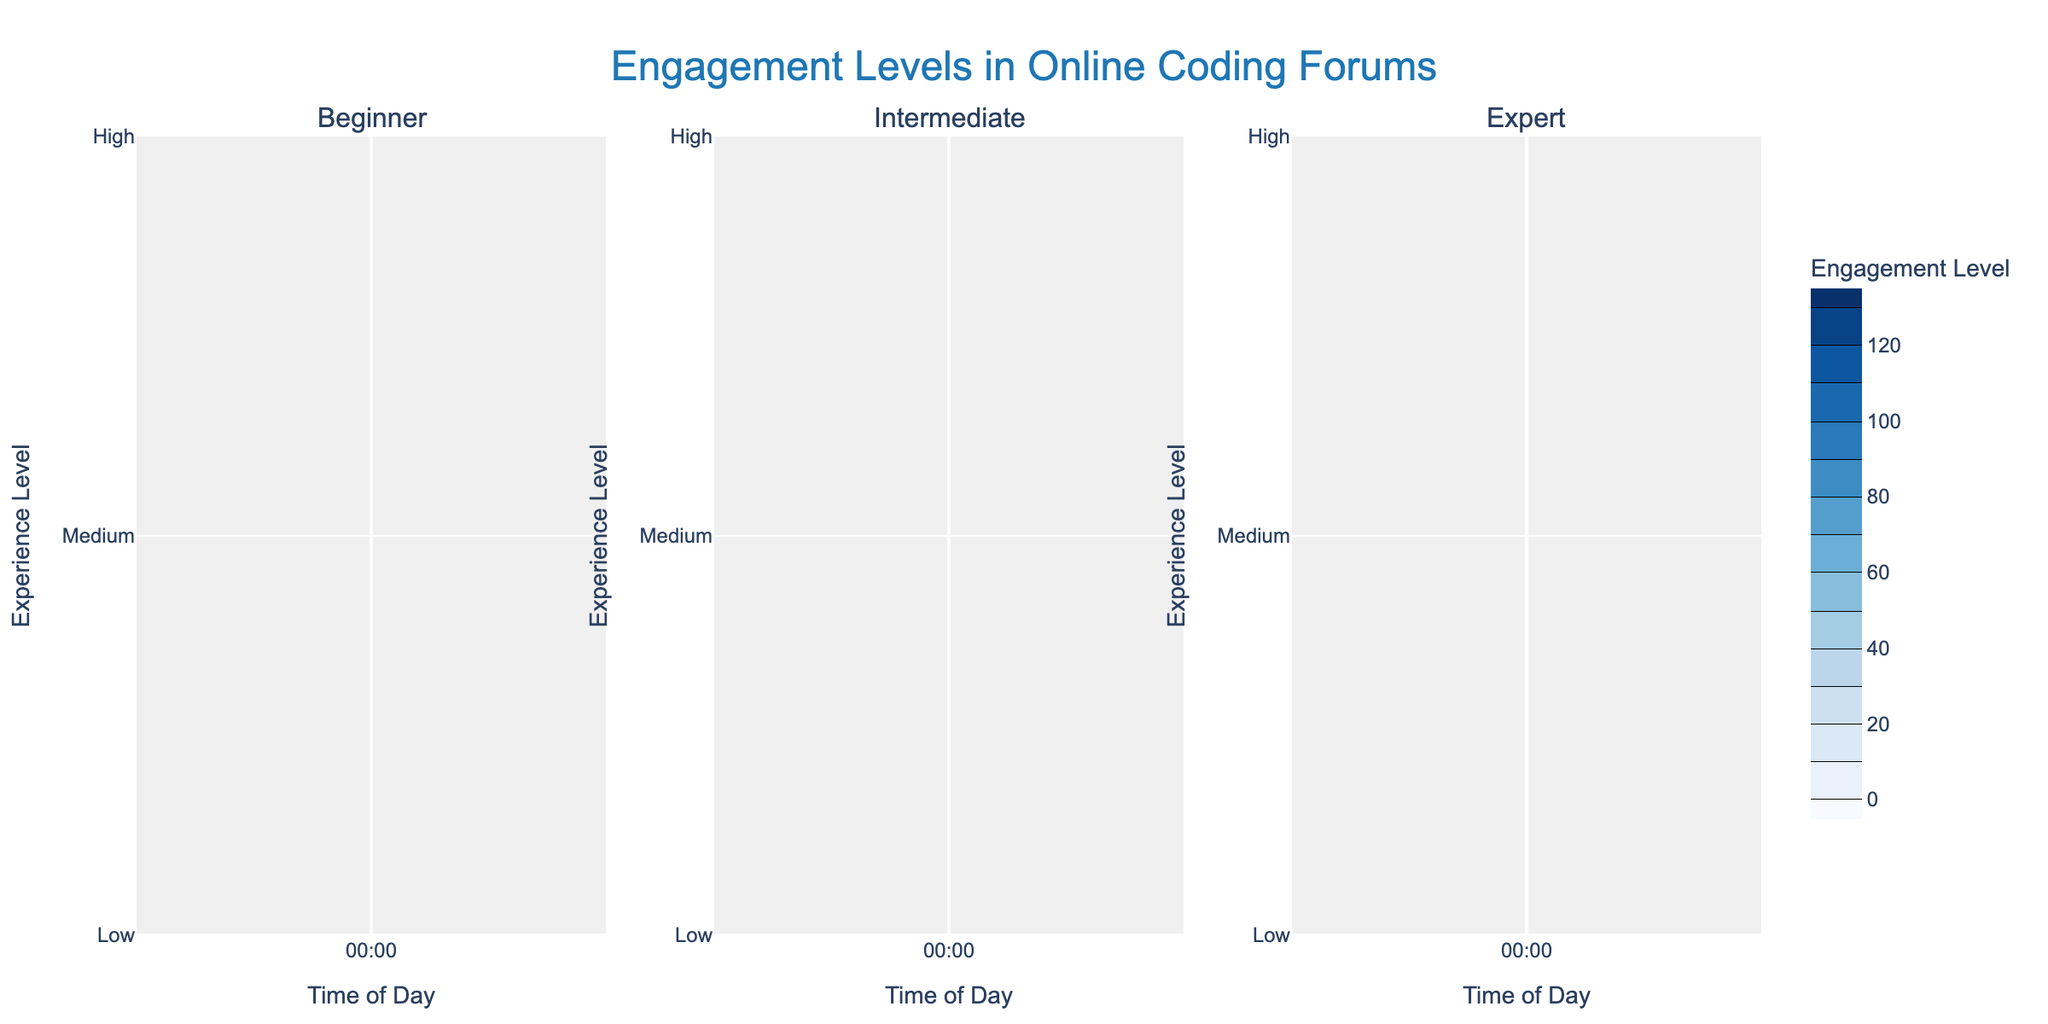What are the titles of the three subplots? The three subplots are titled 'Beginner', 'Intermediate', and 'Expert' based on the user's experience level.
Answer: Beginner, Intermediate, Expert At what time of day is the engagement level highest for beginners? The highest engagement level for beginners is at 23:00 with a value of 130, as shown by the contour plot for the 'Beginner' subplot.
Answer: 23:00 How does the engagement level at 5:00 compare between Beginners and Experts? At 5:00, the contour plots show the engagement level for beginners at 20 and for experts at 22. Hence, the engagement level for beginners is slightly lower than for experts.
Answer: Lower Which user experience level shows the most variation in engagement levels throughout the day? The 'Beginner' subplot shows the most variation throughout the day, with engagement levels ranging from 5 to 130. This can be observed from the wide range of contour lines and colors.
Answer: Beginner What is the engagement level for Intermediate users at 12:00? Referring to the contours in the 'Intermediate' subplot, the engagement level at 12:00 is 78.
Answer: 78 During what time period do Experts have the highest consistent engagement levels? The 'Expert' subplot shows that the engagement levels are highest and consistent from around 17:00 to 23:00, as indicated by the darkest contours within that range.
Answer: 17:00 to 23:00 Which user group maintains the highest engagement level in the early morning (0:00 to 6:00)? Looking at the subplots, Intermediate users maintain the highest engagement level in the early morning hours with peaks of 20 at 0:00, compared to 15 for Beginners and 10 for Experts.
Answer: Intermediate What is the difference in engagement levels between Intermediate and Expert users at 17:00? At 17:00, the engagement level for Intermediate users is 98, while for Expert users, it is 82. The difference is 98 - 82 = 16.
Answer: 16 How does the shape of the contour lines indicate the trend of engagement levels for Beginners throughout the day? The contour lines for Beginners show a gradual increase early in the day, a sharp rise around midday, peaking in the late evening. This indicates a trend of increasing engagement levels as the day progresses.
Answer: Increasing throughout the day, peaking in the evening 